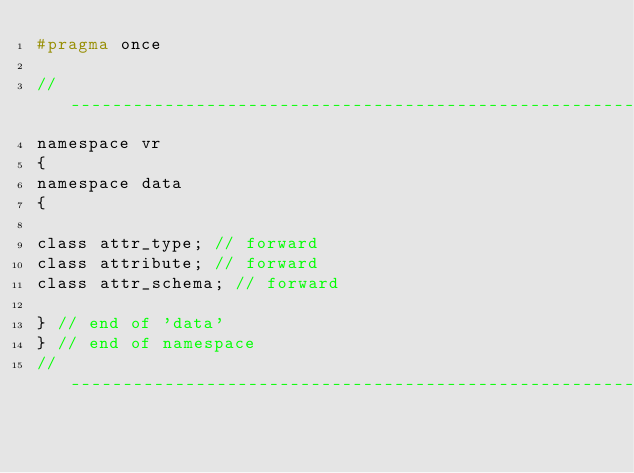<code> <loc_0><loc_0><loc_500><loc_500><_C_>#pragma once

//----------------------------------------------------------------------------
namespace vr
{
namespace data
{

class attr_type; // forward
class attribute; // forward
class attr_schema; // forward

} // end of 'data'
} // end of namespace
//----------------------------------------------------------------------------
</code> 